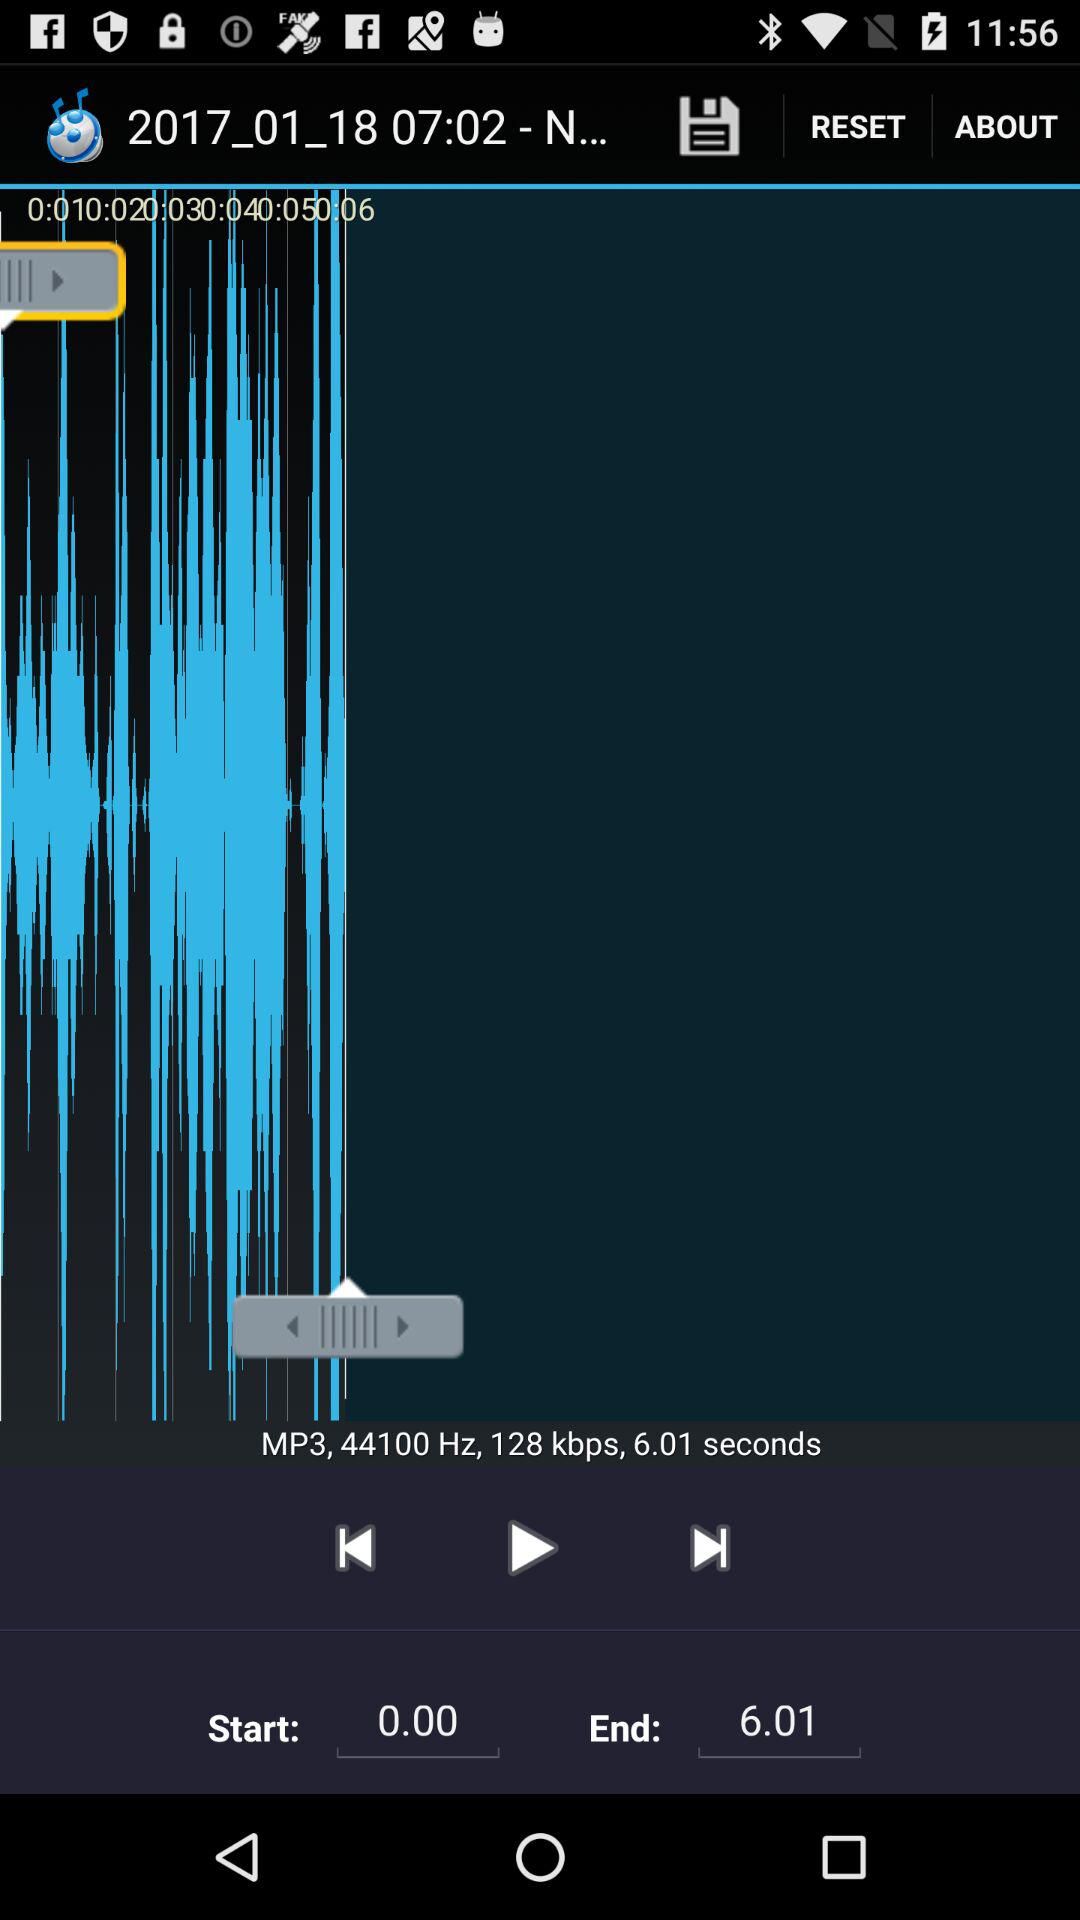How many seconds are between the start and end times?
Answer the question using a single word or phrase. 6.01 